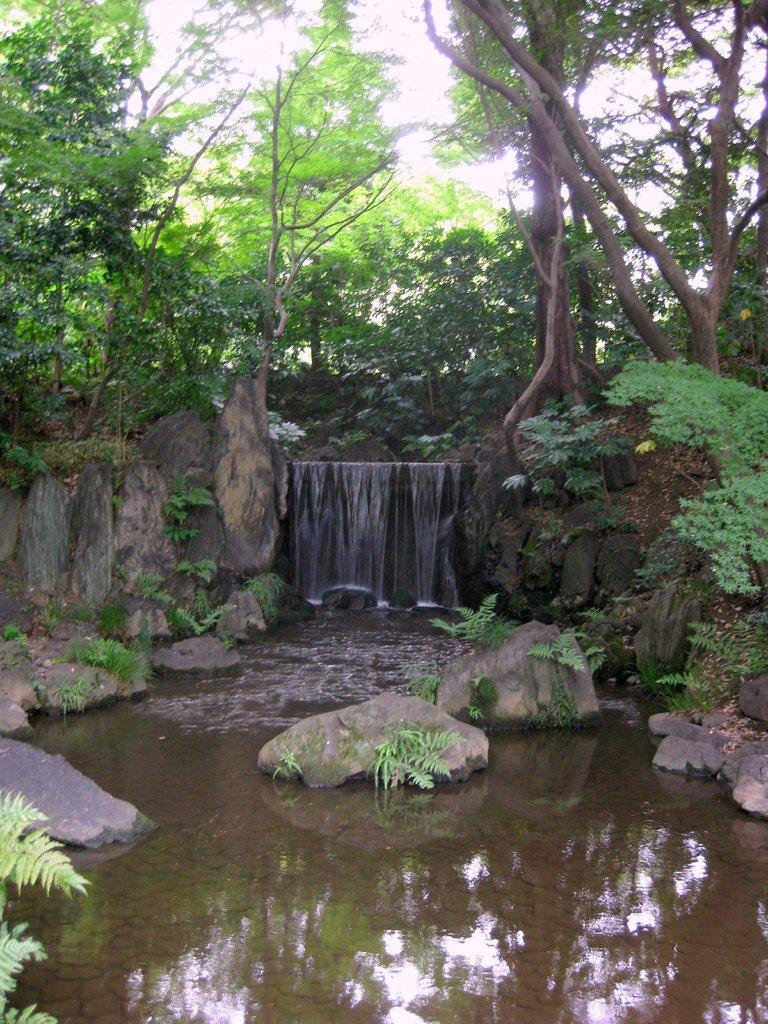What is the primary element visible in the image? There is water in the image. What other objects can be seen in the image? There are stones in the image. What can be seen in the background of the image? There are trees and the sky in the background of the image. How would you describe the sky in the image? The sky is clear and visible in the background of the image. What type of music can be heard playing in the background of the image? There is no music present in the image, as it is a still image and not a video or audio recording. 